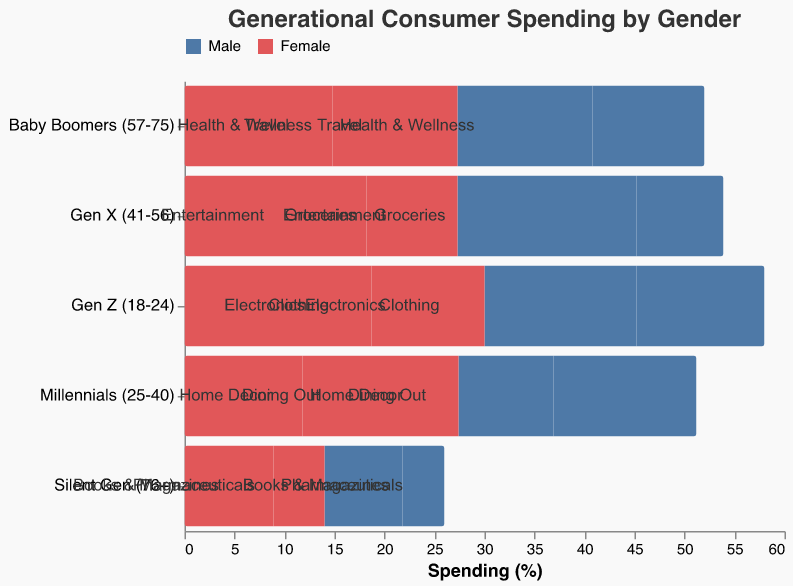What is the title of the figure? The title of the figure is displayed prominently at the top and reads "Generational Consumer Spending by Gender".
Answer: Generational Consumer Spending by Gender Which generation has the highest percentage of spending by females in Clothing? The figure shows that the highest percentage of spending by females in Clothing is among the "Gen Z (18-24)" generation with 18.7%.
Answer: Gen Z (18-24) Which category shows the smallest difference in spending between males and females for the Silent Gen (76+)? For the Silent Gen (76+), "Books & Magazines" has the smallest difference in spending percentages: 5.1% for females and -4.2% for males, which is a difference of 9.3 percentage points.
Answer: Books & Magazines Compare the spending in Entertainment by Gen X males and females. Which gender spends more and by how much? In the Entertainment category for Gen X, females spend 9.1%, while males spend -8.7%. To find the difference, sum the absolute values: 9.1 - 8.7 = 0.4 percentage points.
Answer: Females spend 0.4 percentage points more Which generation and category combination shows the largest negative spending percentage by males? Looking at the male spending percentages, the largest negative value is -17.9% in the "Groceries" category for the Gen X (41-56) generation.
Answer: Gen X (41-56), Groceries What is the total consumer spending percentage for millennials (25-40) in Dining Out, combining both genders? For millennials in Dining Out, the female spending percentage is 15.6% and the male spending percentage is -14.3%. The total spending is 15.6 + (-14.3) = 1.3%.
Answer: 1.3% Which category is most popular among Baby Boomers (57-75) in terms of female spending? Among Baby Boomers, the highest female spending percentage is in "Health & Wellness", with 14.8%.
Answer: Health & Wellness Is the spending percentage for Gen Z males greater in Clothing or Electronics, and by how much? For Gen Z males, the spending percentage in Clothing is -15.2% and in Electronics, it is -12.8%. The difference is -15.2 - (-12.8) = -2.4 percentage points.
Answer: Electronics by 2.4 percentage points Summarize the spending habits of the Silent Gen (76+) in Pharmaceuticals. The spending habits in Pharmaceuticals for the Silent Gen show 8.9% for females and -7.8% for males.
Answer: 8.9% females, -7.8% males 